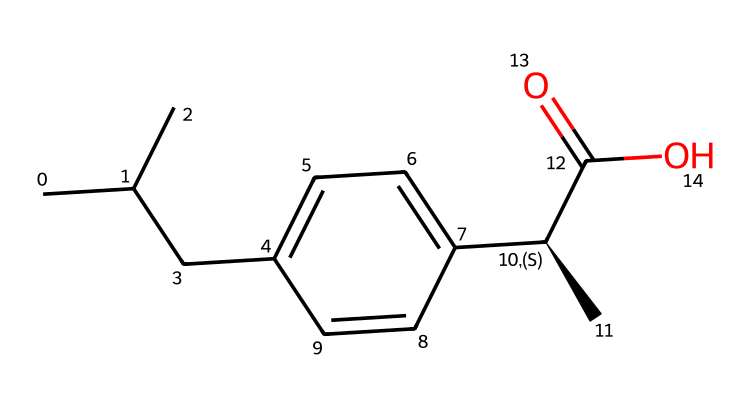What is the total number of carbon atoms in ibuprofen? In the provided SMILES representation, each "C" represents a carbon atom. Counting the total "C" characters, we find there are 13 carbon atoms in the structure of ibuprofen.
Answer: 13 How many chiral centers are present in ibuprofen? A chiral center in a molecule is a carbon atom bonded to four different substituents. In this structure, the chiral center is indicated at the carbon attached to the carbon chain and the aromatic system, leading to one chiral center.
Answer: 1 What functional group is present in ibuprofen? The structural formula of ibuprofen includes a carboxylic acid group (-COOH), identifiable by the -C(=O)O part at the end of the structure. This functional group is responsible for the acidic properties of the molecule.
Answer: carboxylic acid What is the degree of unsaturation in ibuprofen? The degree of unsaturation can be calculated based on the number of rings and multiple bonds. In ibuprofen's structure, the presence of one aromatic ring and a double bond in the carboxylic acid contributes to the degree of unsaturation, leading to a total of 5.
Answer: 5 Which segment of ibuprofen interacts primarily with pain receptors? The carboxylic acid group in ibuprofen is critical for its interaction with pain receptors (COX enzymes). The specific -COOH part is the functional group responsible for the drug's activity in reducing pain and inflammation.
Answer: -COOH What is the geometric shape around the chiral center in ibuprofen? The geometry around the chiral center is tetrahedral because the carbon atom is bonded to four different substituents, resulting in a three-dimensional shape. This tetrahedral geometry is characteristic of sp3 hybridized carbon atoms.
Answer: tetrahedral 